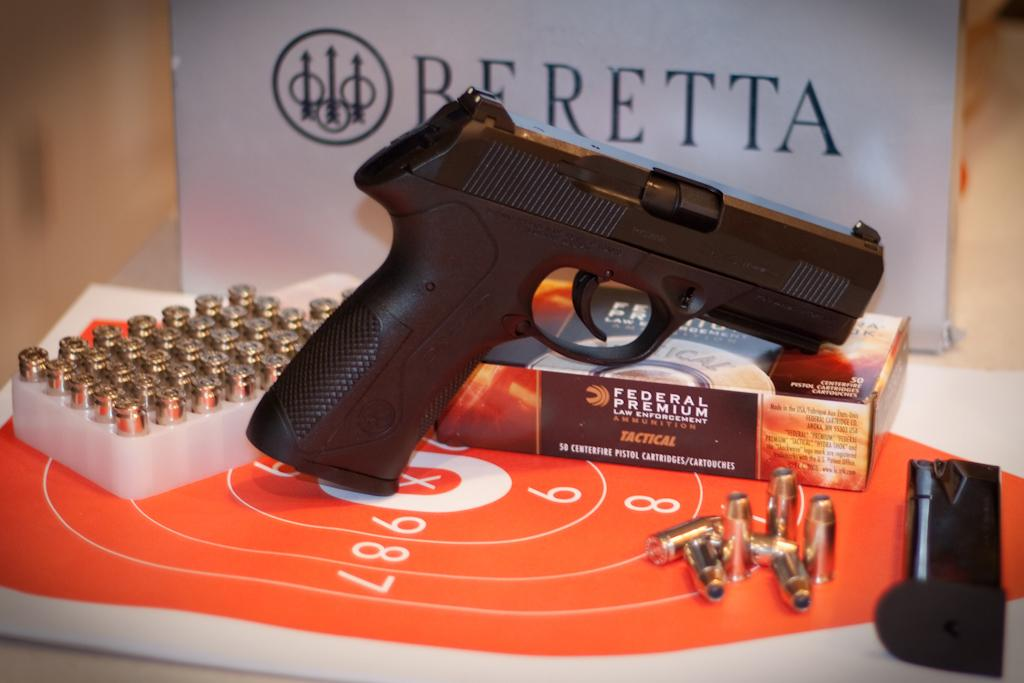What is located in the foreground of the image? There is a board, bullets, a gun, and a box on a table in the foreground of the image. What is the primary object in the foreground of the image? The primary object in the foreground of the image is a gun. What is present on the table in the foreground of the image? There is a box on a table in the foreground of the image. What can be seen in the background of the image? There is a board and a wall in the background of the image. What type of location might the image be taken in? The image is likely taken in a hall. Can you tell me how many dimes are on the table in the image? There is no mention of dimes in the image, so it is not possible to determine their presence or quantity. What type of twig is used to hold the board in the background of the image? There is no twig present in the image; the board is simply located in the background. 